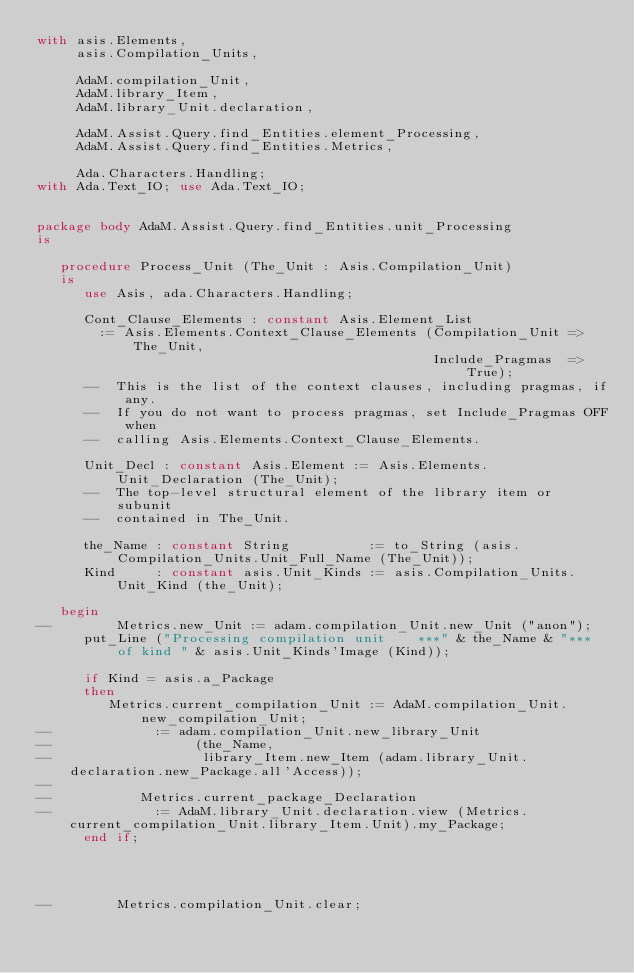<code> <loc_0><loc_0><loc_500><loc_500><_Ada_>with asis.Elements,
     asis.Compilation_Units,

     AdaM.compilation_Unit,
     AdaM.library_Item,
     AdaM.library_Unit.declaration,

     AdaM.Assist.Query.find_Entities.element_Processing,
     AdaM.Assist.Query.find_Entities.Metrics,

     Ada.Characters.Handling;
with Ada.Text_IO; use Ada.Text_IO;


package body AdaM.Assist.Query.find_Entities.unit_Processing
is

   procedure Process_Unit (The_Unit : Asis.Compilation_Unit)
   is
      use Asis, ada.Characters.Handling;

      Cont_Clause_Elements : constant Asis.Element_List
        := Asis.Elements.Context_Clause_Elements (Compilation_Unit => The_Unit,
                                                  Include_Pragmas  => True);
      --  This is the list of the context clauses, including pragmas, if any.
      --  If you do not want to process pragmas, set Include_Pragmas OFF when
      --  calling Asis.Elements.Context_Clause_Elements.

      Unit_Decl : constant Asis.Element := Asis.Elements.Unit_Declaration (The_Unit);
      --  The top-level structural element of the library item or subunit
      --  contained in The_Unit.

      the_Name : constant String          := to_String (asis.Compilation_Units.Unit_Full_Name (The_Unit));
      Kind     : constant asis.Unit_Kinds := asis.Compilation_Units.Unit_Kind (the_Unit);

   begin
--        Metrics.new_Unit := adam.compilation_Unit.new_Unit ("anon");
      put_Line ("Processing compilation unit    ***" & the_Name & "***  of kind " & asis.Unit_Kinds'Image (Kind));

      if Kind = asis.a_Package
      then
         Metrics.current_compilation_Unit := AdaM.compilation_Unit.new_compilation_Unit;
--             := adam.compilation_Unit.new_library_Unit
--                  (the_Name,
--                   library_Item.new_Item (adam.library_Unit.declaration.new_Package.all'Access));
--
--           Metrics.current_package_Declaration
--             := AdaM.library_Unit.declaration.view (Metrics.current_compilation_Unit.library_Item.Unit).my_Package;
      end if;




--        Metrics.compilation_Unit.clear;</code> 